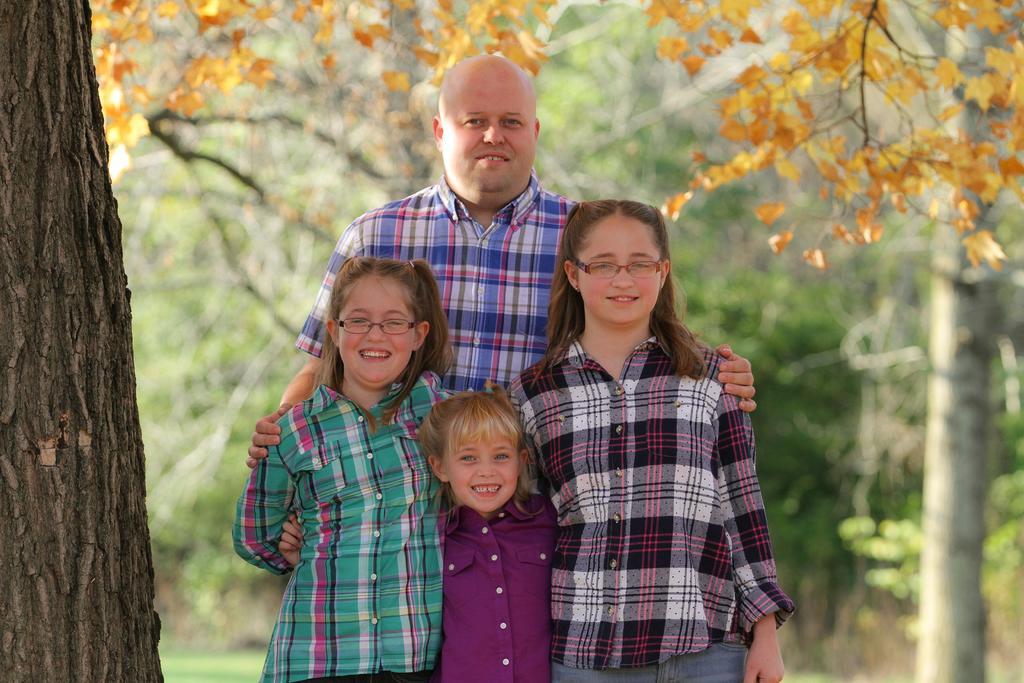Who or what is present in the image? There are people in the image. Can you describe any specific features of the people? Some of the people are wearing glasses. What can be seen in the background of the image? There are trees in the background of the image. How many boxes can be seen stacked on top of each other in the image? There are no boxes present in the image. What time is indicated by the clocks in the image? There are no clocks present in the image. 